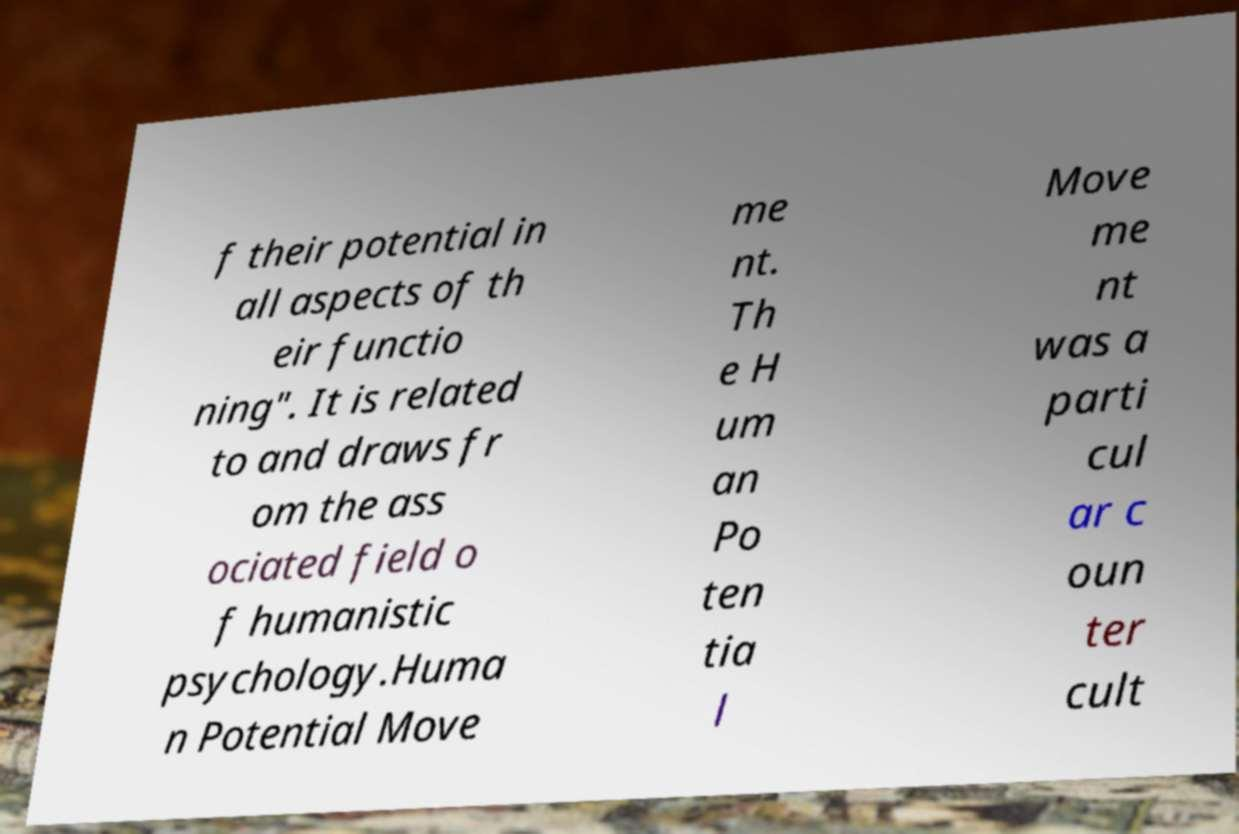For documentation purposes, I need the text within this image transcribed. Could you provide that? f their potential in all aspects of th eir functio ning". It is related to and draws fr om the ass ociated field o f humanistic psychology.Huma n Potential Move me nt. Th e H um an Po ten tia l Move me nt was a parti cul ar c oun ter cult 